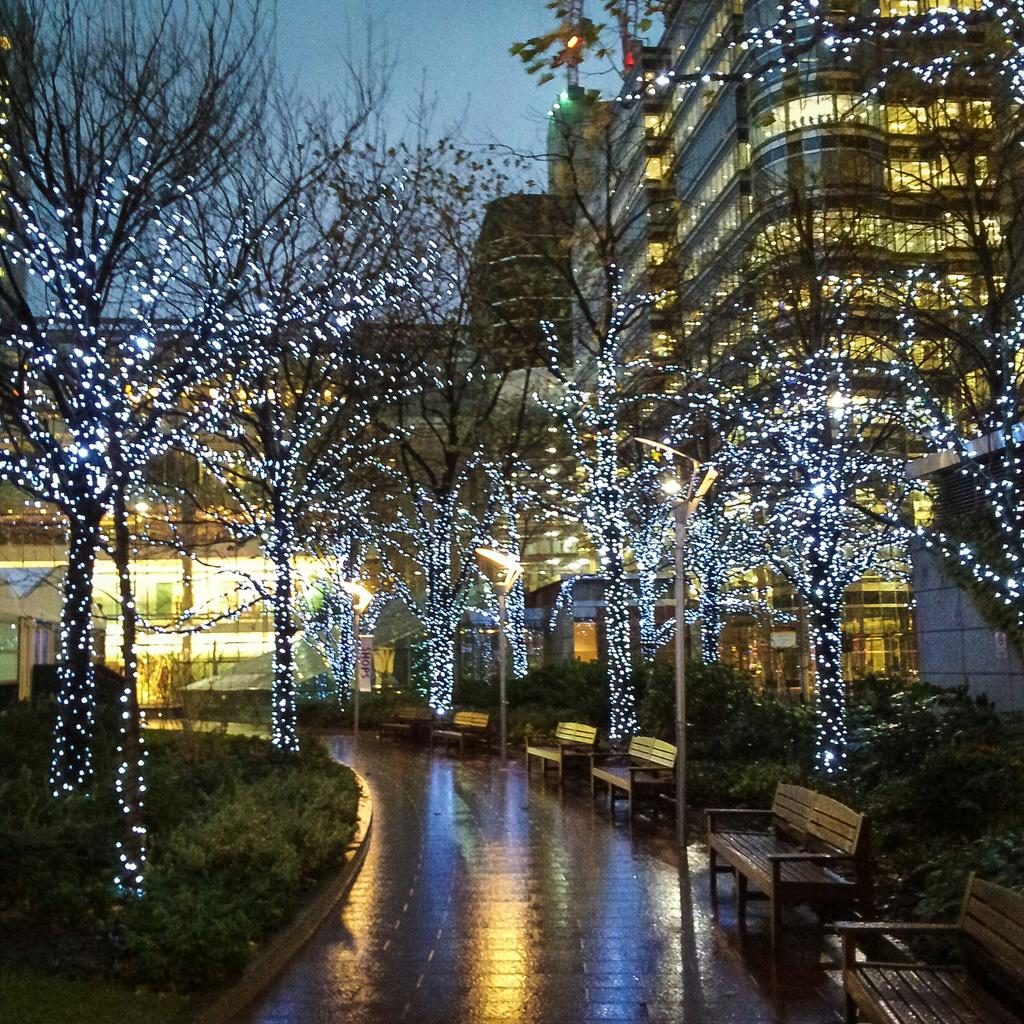What type of furniture is located in the left corner of the image? There are wooden chairs in the left corner of the image. What is unique about the trees near the chairs? The trees are decorated with lights on either side of the chairs. What can be seen in the distance behind the chairs and trees? There are buildings visible in the background of the image. How does the love between the trees grow in the image? There is no love or growth depicted between the trees in the image; they are simply decorated with lights. What type of shoe is visible on the chair in the image? There is no shoe present on the chairs or anywhere else in the image. 